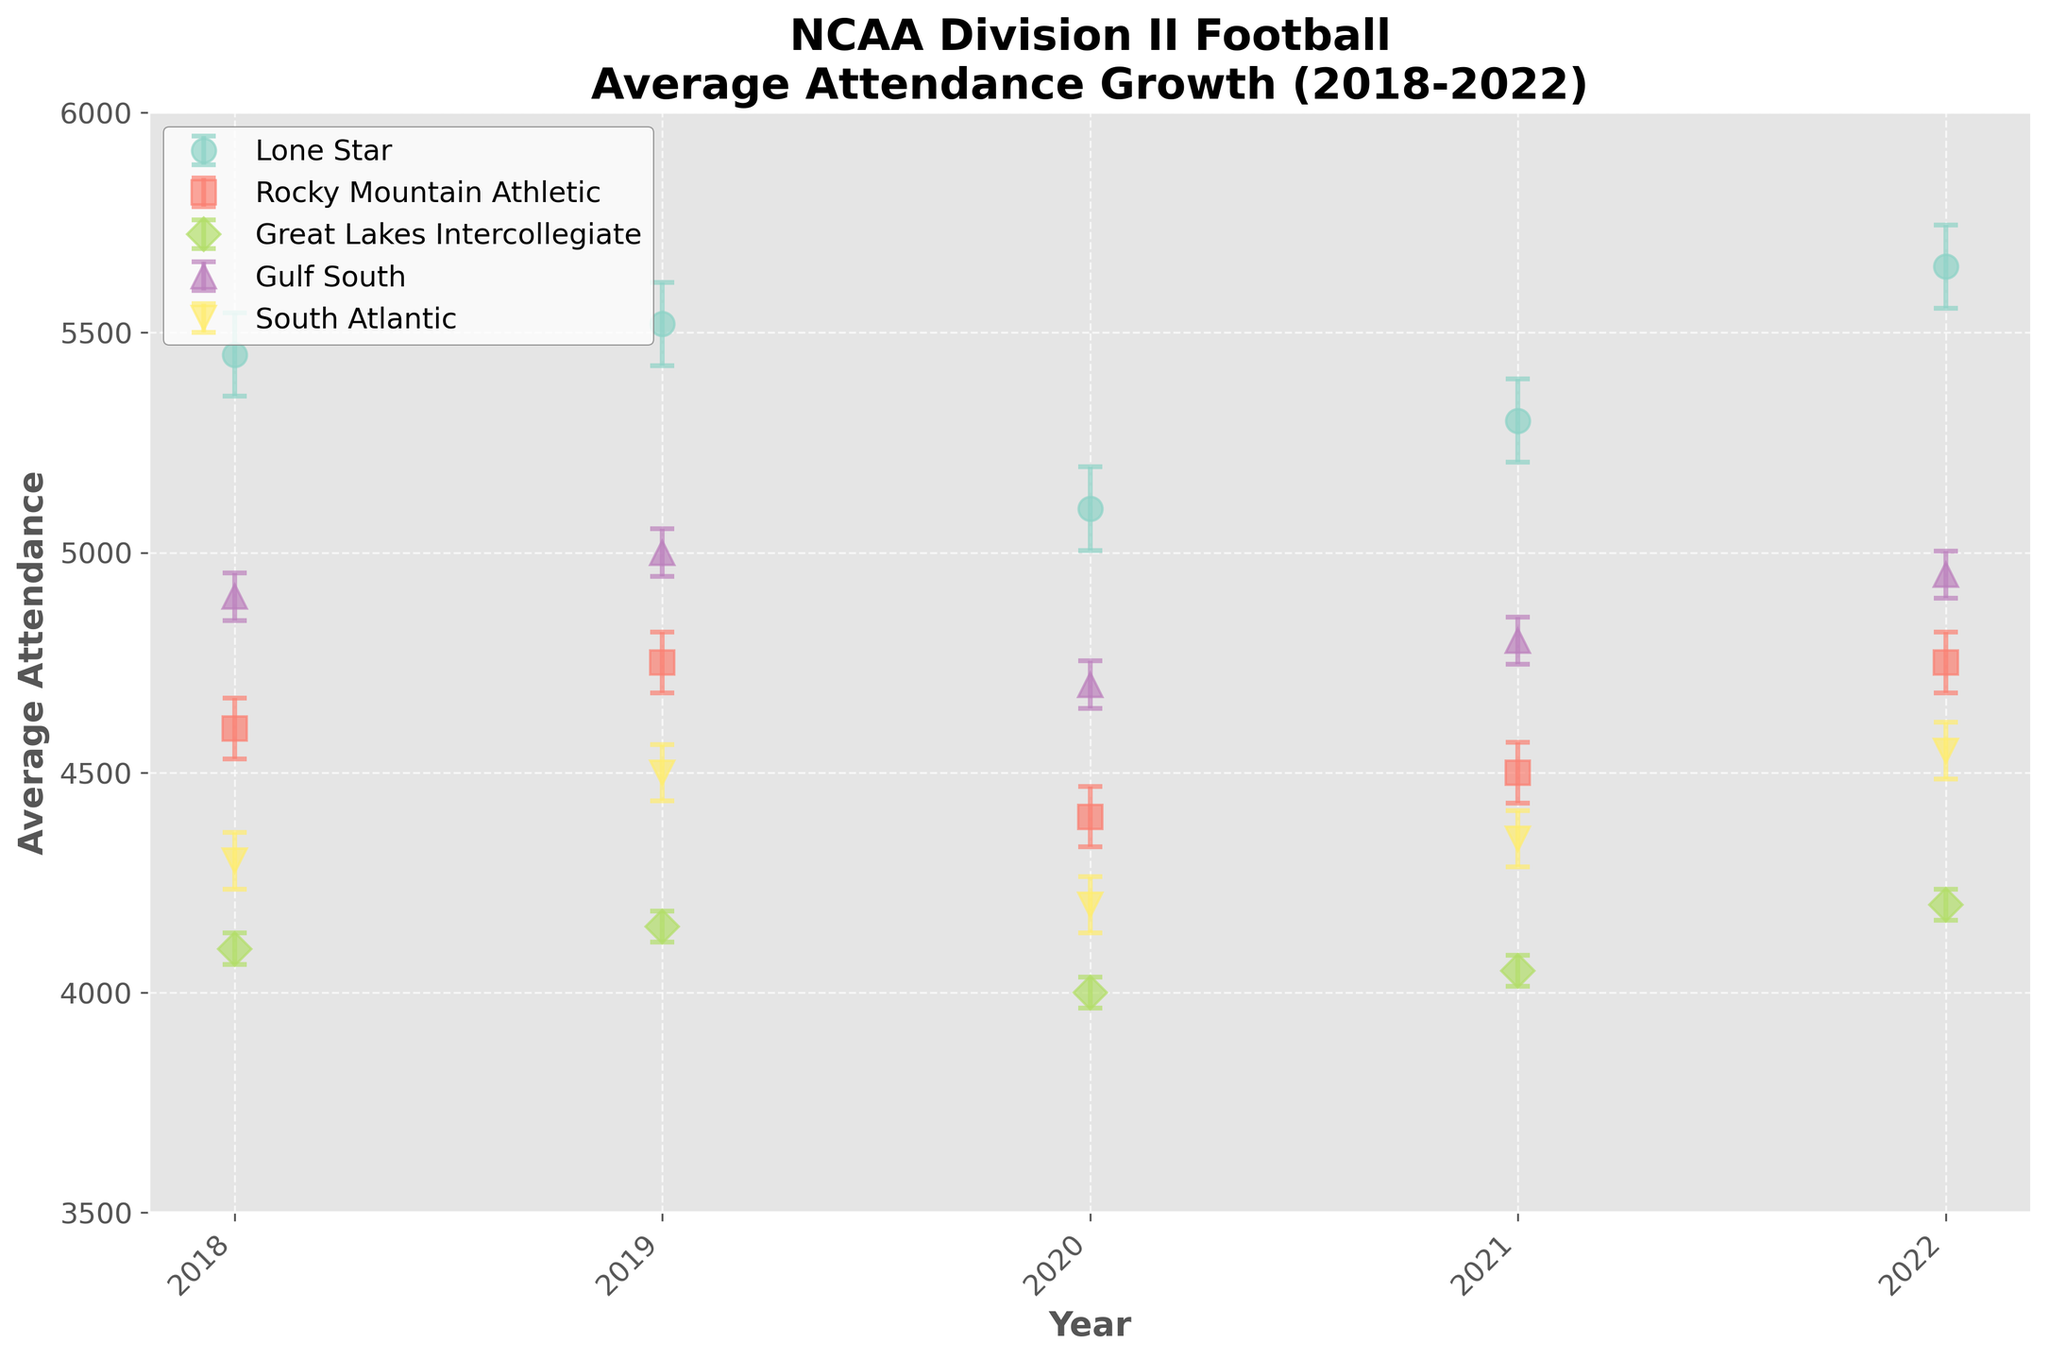What is the title of the plot? The title can be found at the top of the plot, which summarizes the main focus.
Answer: NCAA Division II Football Average Attendance Growth (2018-2022) How many conferences are displayed in the plot? Count the different colored lines or the labels in the legend to determine the number of conferences.
Answer: Five Which conference has the highest average attendance in 2022? Look at the values on the 2022 tick (last tick on the x-axis) and find the highest value among all conference lines.
Answer: Lone Star What is the range of average attendance for the Gulf South conference from 2018 to 2022? Identify the Gulf South line and note the highest and lowest values from 2018 to 2022, then calculate the difference.
Answer: 300 (5000-4700) Which conference shows the most noticeable growth in average attendance in 2022 compared to 2021? Compare the data points of 2021 and 2022 for each conference and identify the most significant increase.
Answer: Lone Star What is the primary color used to represent the Rocky Mountain Athletic conference? Check the legend for the color assigned to the Rocky Mountain Athletic conference.
Answer: Likely a distinctive color like orange or purple, but check the plot to confirm Do any conferences show a decline in average attendance from 2018 to 2022? Look at each conference line from 2018 to 2022 and identify if any end points are lower than the start points.
Answer: No How does the average attendance for the South Atlantic conference in 2020 compare with 2021? Check the data points for the South Atlantic conference in 2020 and 2021 and compare the values.
Answer: It increased from 4200 to 4350 Which conference has the most consistent average attendance over the five years based on the size of the error bars? Look for the conference where the size of the error bars remains smallest over the years.
Answer: Great Lakes Intercollegiate What is the difference in average attendance between the Lone Star and South Atlantic conferences in 2022? Subtract the 2022 value of the South Atlantic conference from that of the Lone Star conference.
Answer: 1100 (5650-4550) 